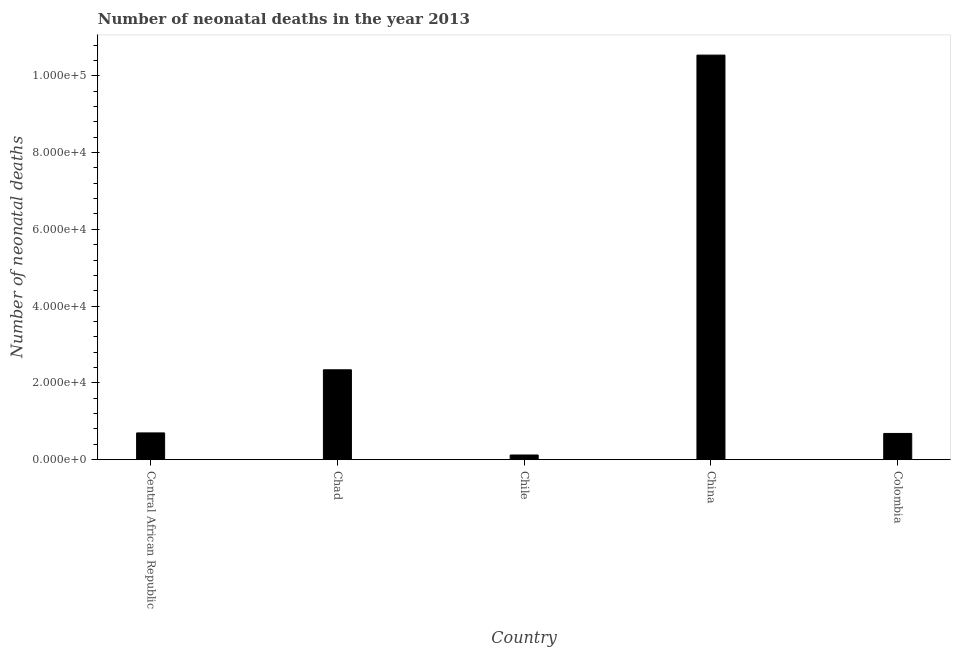Does the graph contain grids?
Ensure brevity in your answer.  No. What is the title of the graph?
Keep it short and to the point. Number of neonatal deaths in the year 2013. What is the label or title of the Y-axis?
Provide a succinct answer. Number of neonatal deaths. What is the number of neonatal deaths in Chile?
Ensure brevity in your answer.  1223. Across all countries, what is the maximum number of neonatal deaths?
Give a very brief answer. 1.05e+05. Across all countries, what is the minimum number of neonatal deaths?
Your answer should be very brief. 1223. In which country was the number of neonatal deaths minimum?
Your answer should be very brief. Chile. What is the sum of the number of neonatal deaths?
Your answer should be compact. 1.44e+05. What is the difference between the number of neonatal deaths in Central African Republic and Chad?
Your answer should be very brief. -1.64e+04. What is the average number of neonatal deaths per country?
Your answer should be very brief. 2.88e+04. What is the median number of neonatal deaths?
Offer a very short reply. 6974. What is the ratio of the number of neonatal deaths in Central African Republic to that in Chile?
Keep it short and to the point. 5.7. Is the difference between the number of neonatal deaths in Central African Republic and Chile greater than the difference between any two countries?
Your response must be concise. No. What is the difference between the highest and the second highest number of neonatal deaths?
Offer a terse response. 8.20e+04. Is the sum of the number of neonatal deaths in Chad and China greater than the maximum number of neonatal deaths across all countries?
Offer a terse response. Yes. What is the difference between the highest and the lowest number of neonatal deaths?
Ensure brevity in your answer.  1.04e+05. In how many countries, is the number of neonatal deaths greater than the average number of neonatal deaths taken over all countries?
Your response must be concise. 1. How many countries are there in the graph?
Offer a very short reply. 5. What is the difference between two consecutive major ticks on the Y-axis?
Your answer should be compact. 2.00e+04. What is the Number of neonatal deaths in Central African Republic?
Make the answer very short. 6974. What is the Number of neonatal deaths in Chad?
Your answer should be very brief. 2.34e+04. What is the Number of neonatal deaths of Chile?
Ensure brevity in your answer.  1223. What is the Number of neonatal deaths in China?
Provide a succinct answer. 1.05e+05. What is the Number of neonatal deaths of Colombia?
Provide a short and direct response. 6837. What is the difference between the Number of neonatal deaths in Central African Republic and Chad?
Ensure brevity in your answer.  -1.64e+04. What is the difference between the Number of neonatal deaths in Central African Republic and Chile?
Offer a very short reply. 5751. What is the difference between the Number of neonatal deaths in Central African Republic and China?
Make the answer very short. -9.84e+04. What is the difference between the Number of neonatal deaths in Central African Republic and Colombia?
Ensure brevity in your answer.  137. What is the difference between the Number of neonatal deaths in Chad and Chile?
Provide a succinct answer. 2.22e+04. What is the difference between the Number of neonatal deaths in Chad and China?
Give a very brief answer. -8.20e+04. What is the difference between the Number of neonatal deaths in Chad and Colombia?
Your response must be concise. 1.66e+04. What is the difference between the Number of neonatal deaths in Chile and China?
Provide a succinct answer. -1.04e+05. What is the difference between the Number of neonatal deaths in Chile and Colombia?
Provide a succinct answer. -5614. What is the difference between the Number of neonatal deaths in China and Colombia?
Offer a very short reply. 9.85e+04. What is the ratio of the Number of neonatal deaths in Central African Republic to that in Chad?
Keep it short and to the point. 0.3. What is the ratio of the Number of neonatal deaths in Central African Republic to that in Chile?
Keep it short and to the point. 5.7. What is the ratio of the Number of neonatal deaths in Central African Republic to that in China?
Offer a terse response. 0.07. What is the ratio of the Number of neonatal deaths in Central African Republic to that in Colombia?
Give a very brief answer. 1.02. What is the ratio of the Number of neonatal deaths in Chad to that in Chile?
Make the answer very short. 19.14. What is the ratio of the Number of neonatal deaths in Chad to that in China?
Provide a succinct answer. 0.22. What is the ratio of the Number of neonatal deaths in Chad to that in Colombia?
Make the answer very short. 3.42. What is the ratio of the Number of neonatal deaths in Chile to that in China?
Your answer should be compact. 0.01. What is the ratio of the Number of neonatal deaths in Chile to that in Colombia?
Your answer should be very brief. 0.18. What is the ratio of the Number of neonatal deaths in China to that in Colombia?
Provide a succinct answer. 15.41. 